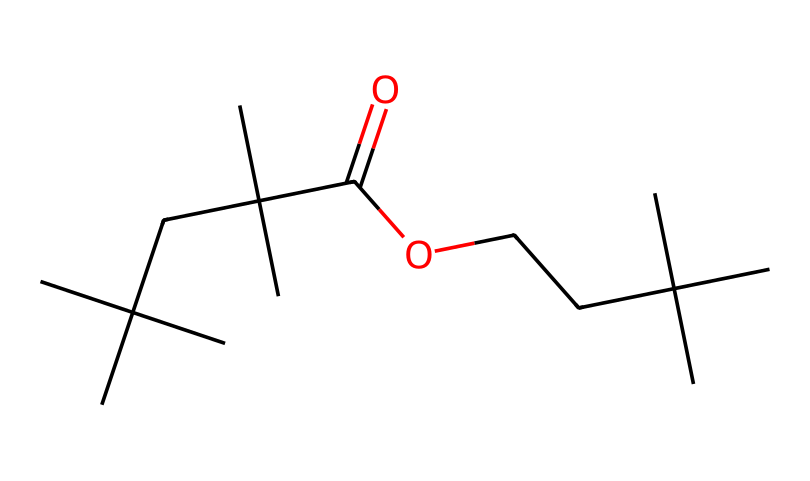What is the primary functional group in this chemical? The structure includes a carboxylic acid group, identifiable by the presence of the -COOH functional group. This is indicated by the carbon that has a double bond with oxygen (carbonyl) and a single bond with a hydroxyl group (OH).
Answer: carboxylic acid How many carbon atoms are present in this compound? By analyzing the SMILES, I can count a total of 15 carbon atoms represented by the 'C' symbols throughout the structure. These include both the carbon backbone and those in the functional group.
Answer: 15 What type of bond connects the carbonyl carbon to the oxygen in the carboxylic acid? The connection between the carbonyl carbon and the oxygen in the carboxylic acid is formed by a double bond, which can be deduced from the 'C(=O)' notation in the SMILES.
Answer: double bond What indicates that this chemical is a branched alkane? The presence of multiple substituents on the carbon chain indicates branching. This is noted from the parentheses in the SMILES, which show tertiary carbon groups attached to a main carbon skeleton, confirming its classification as a branched alkane.
Answer: branching What is the molecular weight (approximate) of this compound? To estimate the molecular weight, we can sum the weights of the individual atoms: each carbon contributes approximately 12 g/mol, each hydrogen 1 g/mol, and each oxygen about 16 g/mol. From the earlier analysis of 15 carbons, 30 hydrogens, and 2 oxygens, the calculation leads to approximately 242 g/mol.
Answer: 242 g/mol 